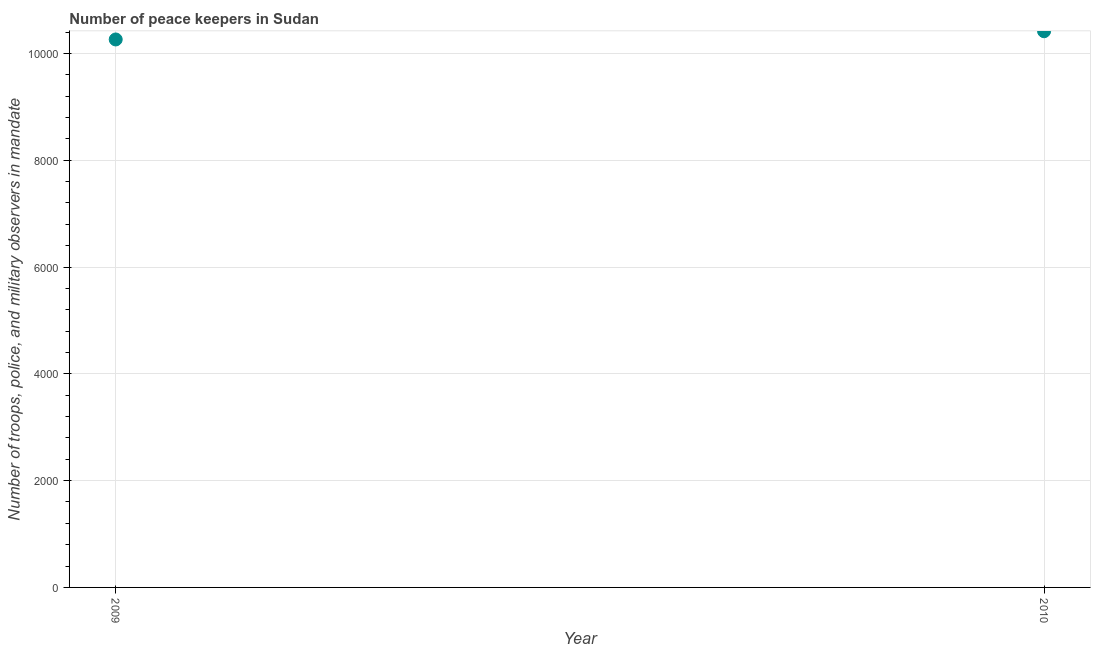What is the number of peace keepers in 2009?
Your answer should be compact. 1.03e+04. Across all years, what is the maximum number of peace keepers?
Make the answer very short. 1.04e+04. Across all years, what is the minimum number of peace keepers?
Provide a short and direct response. 1.03e+04. In which year was the number of peace keepers maximum?
Ensure brevity in your answer.  2010. In which year was the number of peace keepers minimum?
Keep it short and to the point. 2009. What is the sum of the number of peace keepers?
Your answer should be very brief. 2.07e+04. What is the difference between the number of peace keepers in 2009 and 2010?
Offer a very short reply. -154. What is the average number of peace keepers per year?
Give a very brief answer. 1.03e+04. What is the median number of peace keepers?
Your response must be concise. 1.03e+04. In how many years, is the number of peace keepers greater than 7600 ?
Provide a succinct answer. 2. Do a majority of the years between 2009 and 2010 (inclusive) have number of peace keepers greater than 4000 ?
Keep it short and to the point. Yes. What is the ratio of the number of peace keepers in 2009 to that in 2010?
Your answer should be compact. 0.99. Is the number of peace keepers in 2009 less than that in 2010?
Your answer should be compact. Yes. How many years are there in the graph?
Ensure brevity in your answer.  2. What is the difference between two consecutive major ticks on the Y-axis?
Keep it short and to the point. 2000. Are the values on the major ticks of Y-axis written in scientific E-notation?
Offer a terse response. No. Does the graph contain any zero values?
Make the answer very short. No. What is the title of the graph?
Make the answer very short. Number of peace keepers in Sudan. What is the label or title of the X-axis?
Give a very brief answer. Year. What is the label or title of the Y-axis?
Your answer should be very brief. Number of troops, police, and military observers in mandate. What is the Number of troops, police, and military observers in mandate in 2009?
Offer a terse response. 1.03e+04. What is the Number of troops, police, and military observers in mandate in 2010?
Your answer should be compact. 1.04e+04. What is the difference between the Number of troops, police, and military observers in mandate in 2009 and 2010?
Provide a short and direct response. -154. What is the ratio of the Number of troops, police, and military observers in mandate in 2009 to that in 2010?
Offer a very short reply. 0.98. 